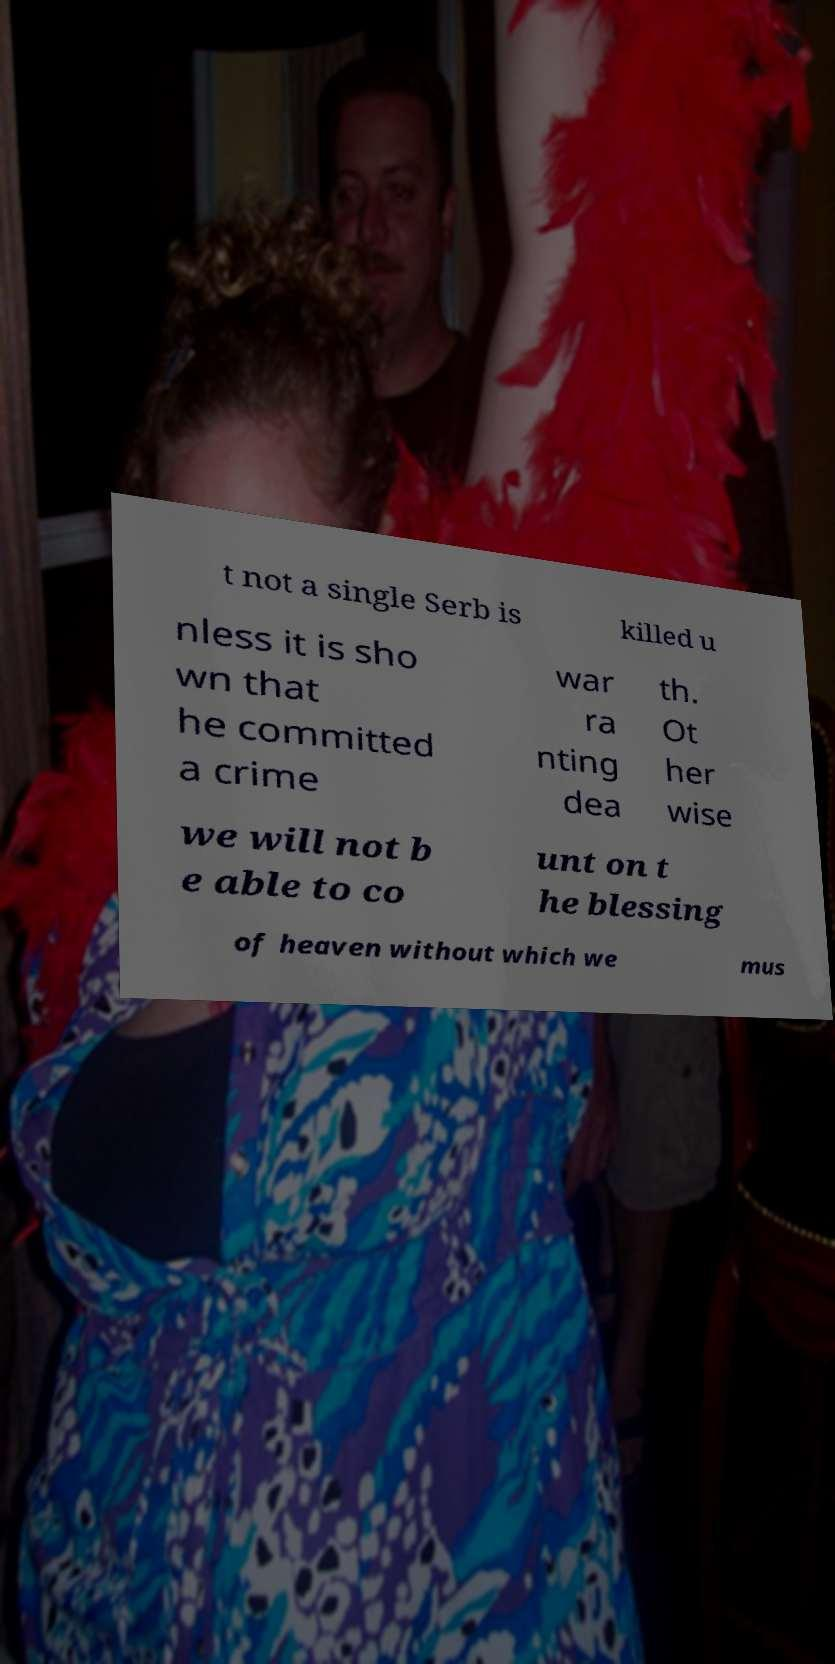What messages or text are displayed in this image? I need them in a readable, typed format. t not a single Serb is killed u nless it is sho wn that he committed a crime war ra nting dea th. Ot her wise we will not b e able to co unt on t he blessing of heaven without which we mus 